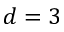Convert formula to latex. <formula><loc_0><loc_0><loc_500><loc_500>d = 3</formula> 